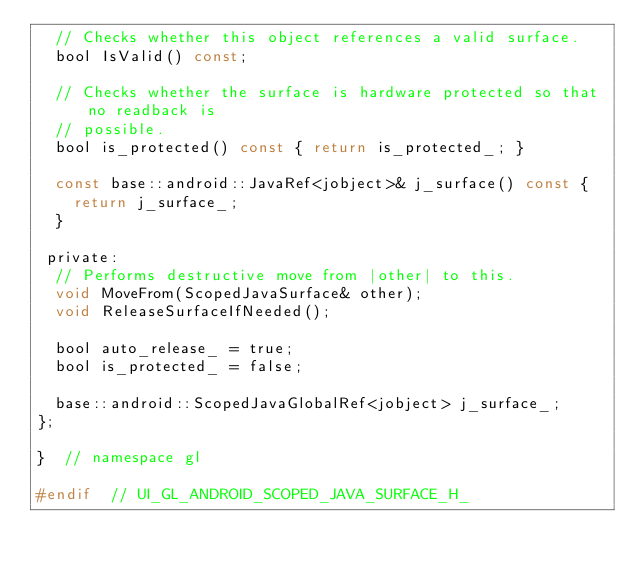<code> <loc_0><loc_0><loc_500><loc_500><_C_>  // Checks whether this object references a valid surface.
  bool IsValid() const;

  // Checks whether the surface is hardware protected so that no readback is
  // possible.
  bool is_protected() const { return is_protected_; }

  const base::android::JavaRef<jobject>& j_surface() const {
    return j_surface_;
  }

 private:
  // Performs destructive move from |other| to this.
  void MoveFrom(ScopedJavaSurface& other);
  void ReleaseSurfaceIfNeeded();

  bool auto_release_ = true;
  bool is_protected_ = false;

  base::android::ScopedJavaGlobalRef<jobject> j_surface_;
};

}  // namespace gl

#endif  // UI_GL_ANDROID_SCOPED_JAVA_SURFACE_H_
</code> 